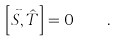<formula> <loc_0><loc_0><loc_500><loc_500>\left [ \vec { S } , \hat { T } \right ] = 0 \quad .</formula> 